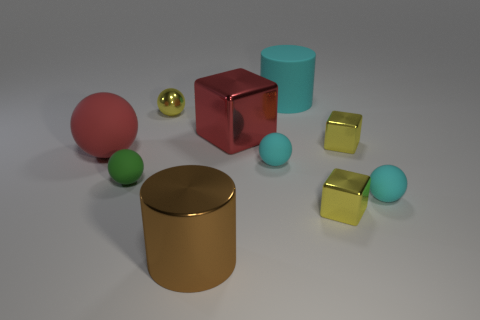Subtract all cyan spheres. How many yellow cubes are left? 2 Subtract all red spheres. How many spheres are left? 4 Subtract all large balls. How many balls are left? 4 Subtract all cubes. How many objects are left? 7 Subtract all brown balls. Subtract all purple cubes. How many balls are left? 5 Add 5 green balls. How many green balls exist? 6 Subtract 2 cyan balls. How many objects are left? 8 Subtract all small red blocks. Subtract all tiny cyan objects. How many objects are left? 8 Add 2 yellow metallic objects. How many yellow metallic objects are left? 5 